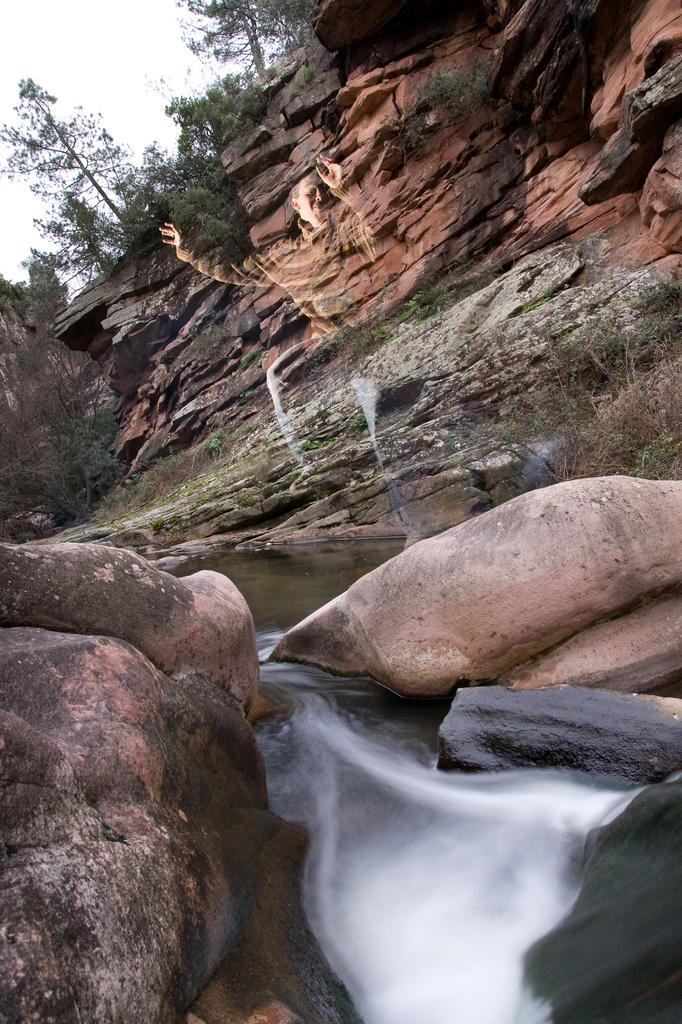What is the main feature in the center of the image? The main feature in the center of the image is a combination of sky, trees, rocks, and water. Can you describe the elements in the center of the image in more detail? Yes, there are trees, rocks, and water present in the center of the image, along with the sky. How are the elements in the center of the image arranged? The elements in the center of the image are arranged in a way that suggests a natural landscape, with trees, rocks, and water all present. What type of birthday celebration is taking place in the image? There is no indication of a birthday celebration in the image; it features a natural landscape with sky, trees, rocks, and water. What is the texture of the rocks in the image? The texture of the rocks cannot be determined from the image alone, as it only provides visual information. 